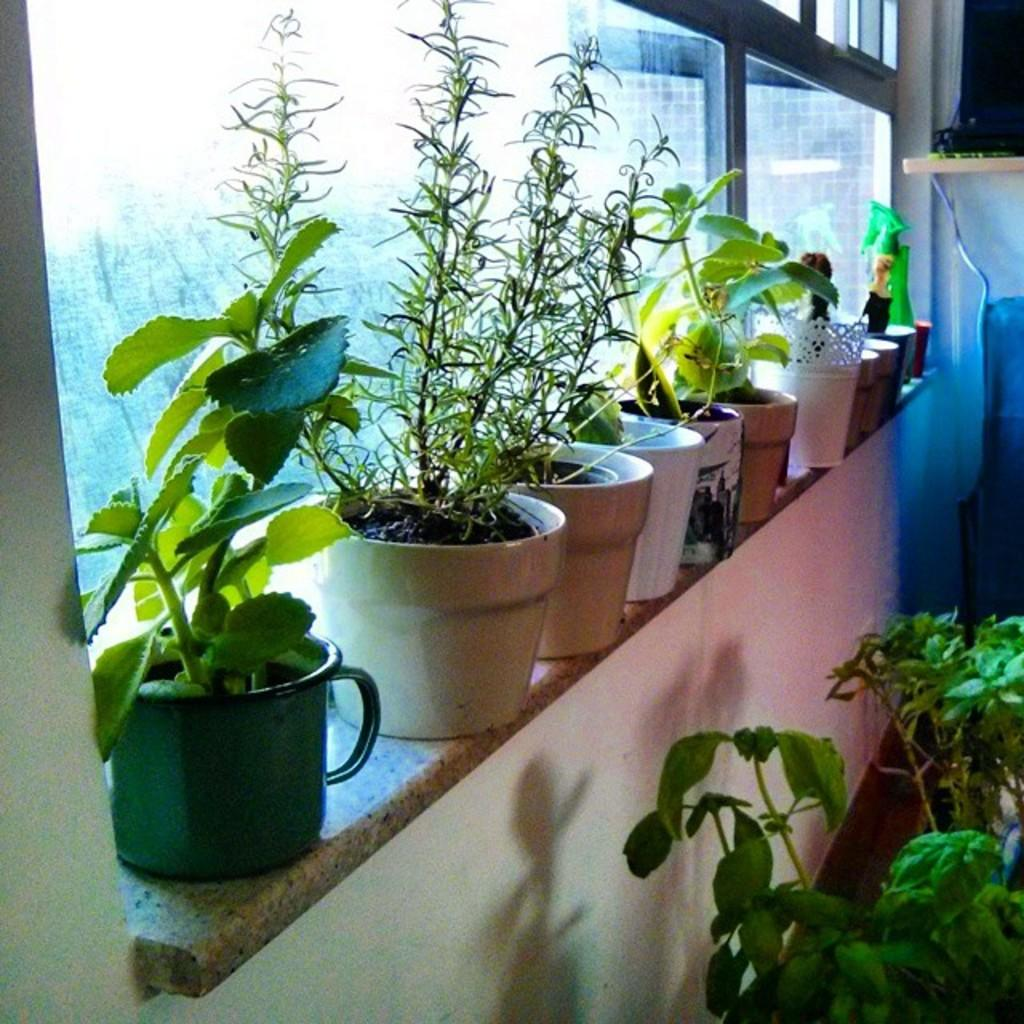What objects are in the image? There are plants in pots in the image. Can you describe the background of the image? There is a green color thing in the background of the image. How many kisses can be seen on the plants in the image? There are no kisses present on the plants in the image. What type of honey is being produced by the plants in the image? There is no honey production by the plants in the image. What type of skirt is being worn by the plants in the image? The plants in the image are not wearing any clothing, including skirts. 